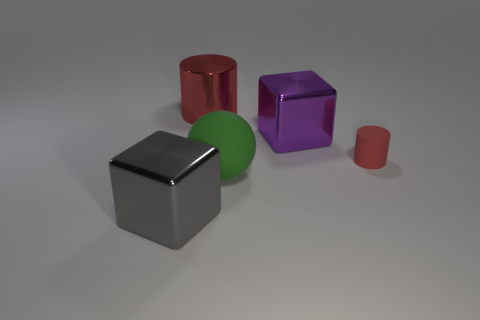Is there any other thing that has the same material as the big green sphere?
Make the answer very short. Yes. Is there another large block that has the same material as the big gray cube?
Offer a very short reply. Yes. What is the material of the gray object that is the same size as the green matte object?
Your answer should be compact. Metal. What number of other small objects have the same shape as the tiny object?
Your answer should be compact. 0. There is a red object that is the same material as the big green sphere; what size is it?
Your response must be concise. Small. What is the material of the object that is both left of the large matte ball and behind the big green sphere?
Keep it short and to the point. Metal. How many purple metal objects are the same size as the metal cylinder?
Ensure brevity in your answer.  1. There is another red object that is the same shape as the tiny rubber object; what is its material?
Give a very brief answer. Metal. How many things are red things that are behind the purple metallic object or large objects behind the gray thing?
Your response must be concise. 3. There is a small thing; does it have the same shape as the red metallic object that is to the left of the red matte cylinder?
Your response must be concise. Yes. 